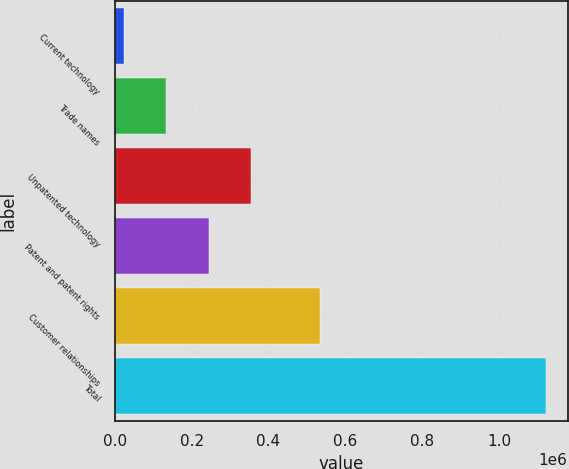<chart> <loc_0><loc_0><loc_500><loc_500><bar_chart><fcel>Current technology<fcel>Trade names<fcel>Unpatented technology<fcel>Patent and patent rights<fcel>Customer relationships<fcel>Total<nl><fcel>23201<fcel>132947<fcel>354315<fcel>244569<fcel>532591<fcel>1.12066e+06<nl></chart> 